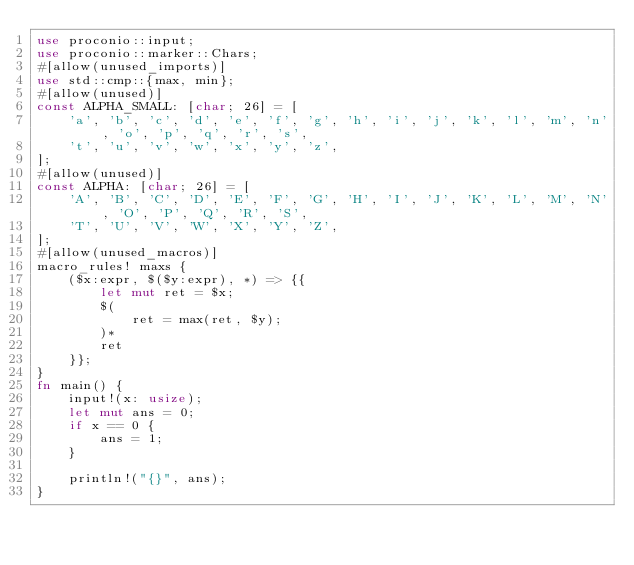Convert code to text. <code><loc_0><loc_0><loc_500><loc_500><_Rust_>use proconio::input;
use proconio::marker::Chars;
#[allow(unused_imports)]
use std::cmp::{max, min};
#[allow(unused)]
const ALPHA_SMALL: [char; 26] = [
    'a', 'b', 'c', 'd', 'e', 'f', 'g', 'h', 'i', 'j', 'k', 'l', 'm', 'n', 'o', 'p', 'q', 'r', 's',
    't', 'u', 'v', 'w', 'x', 'y', 'z',
];
#[allow(unused)]
const ALPHA: [char; 26] = [
    'A', 'B', 'C', 'D', 'E', 'F', 'G', 'H', 'I', 'J', 'K', 'L', 'M', 'N', 'O', 'P', 'Q', 'R', 'S',
    'T', 'U', 'V', 'W', 'X', 'Y', 'Z',
];
#[allow(unused_macros)]
macro_rules! maxs {
    ($x:expr, $($y:expr), *) => {{
        let mut ret = $x;
        $(
            ret = max(ret, $y);
        )*
        ret
    }};
}
fn main() {
    input!(x: usize);
    let mut ans = 0;
    if x == 0 {
        ans = 1;
    }

    println!("{}", ans);
}
</code> 